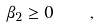Convert formula to latex. <formula><loc_0><loc_0><loc_500><loc_500>\beta _ { 2 } \geq 0 \quad ,</formula> 